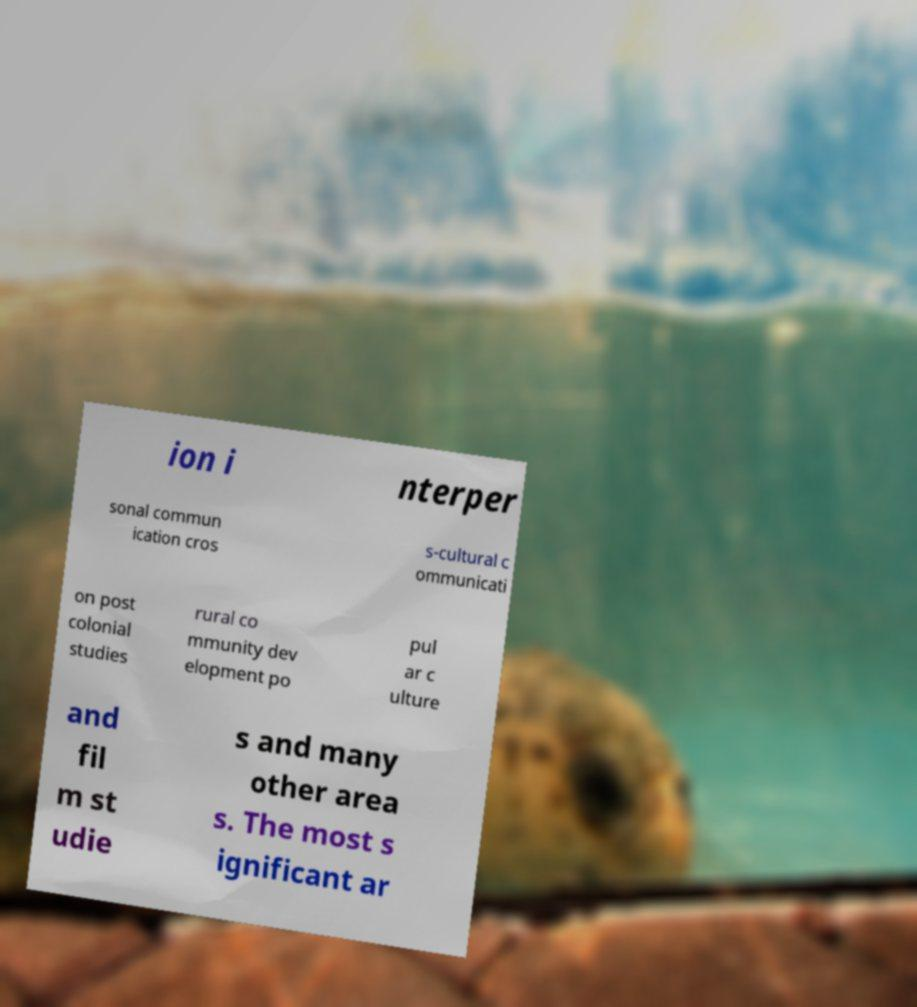There's text embedded in this image that I need extracted. Can you transcribe it verbatim? ion i nterper sonal commun ication cros s-cultural c ommunicati on post colonial studies rural co mmunity dev elopment po pul ar c ulture and fil m st udie s and many other area s. The most s ignificant ar 